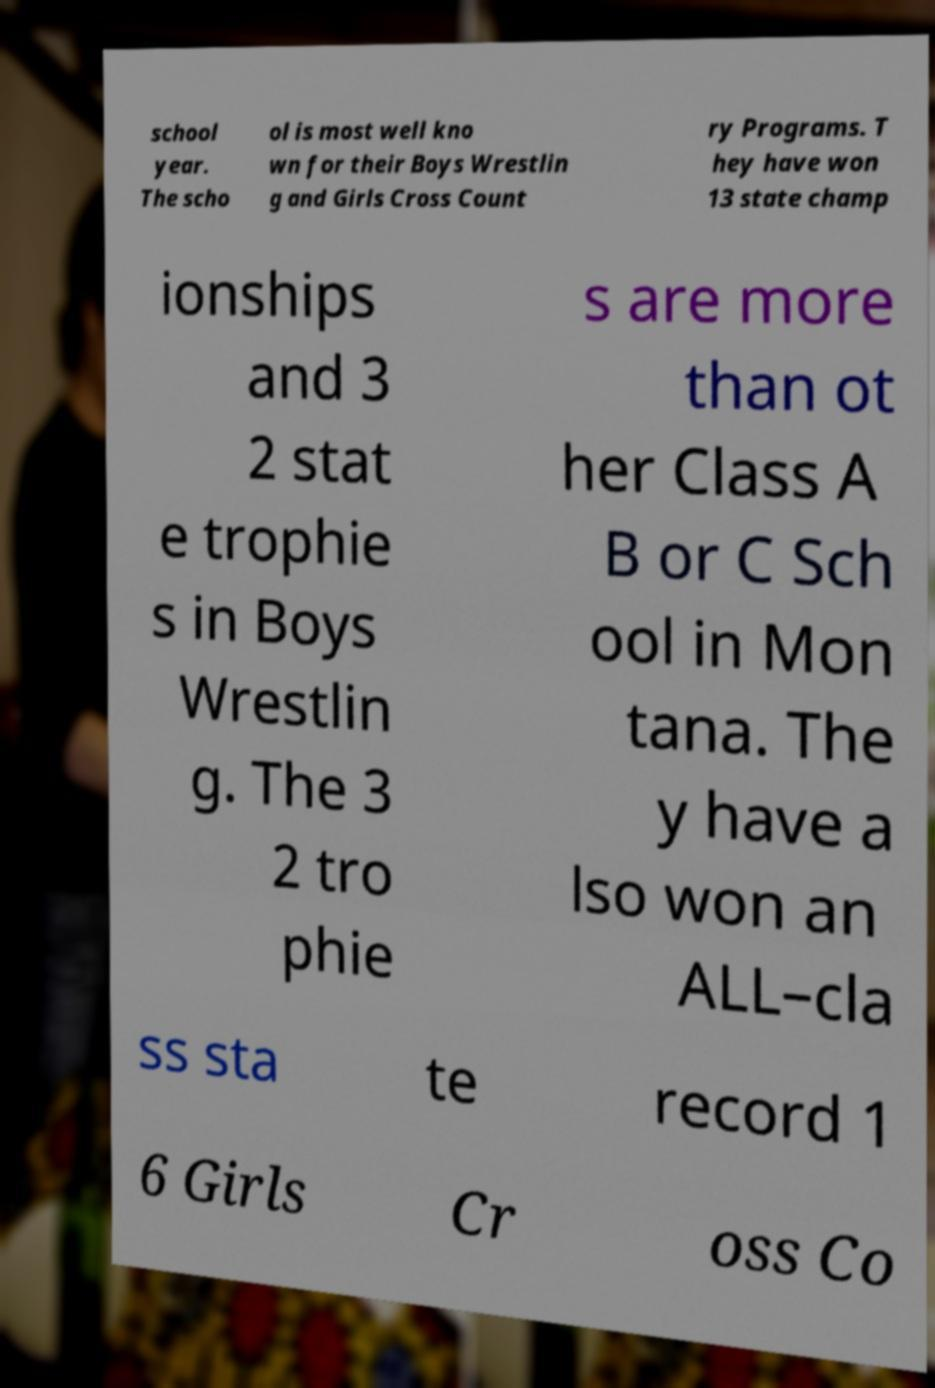What messages or text are displayed in this image? I need them in a readable, typed format. school year. The scho ol is most well kno wn for their Boys Wrestlin g and Girls Cross Count ry Programs. T hey have won 13 state champ ionships and 3 2 stat e trophie s in Boys Wrestlin g. The 3 2 tro phie s are more than ot her Class A B or C Sch ool in Mon tana. The y have a lso won an ALL–cla ss sta te record 1 6 Girls Cr oss Co 